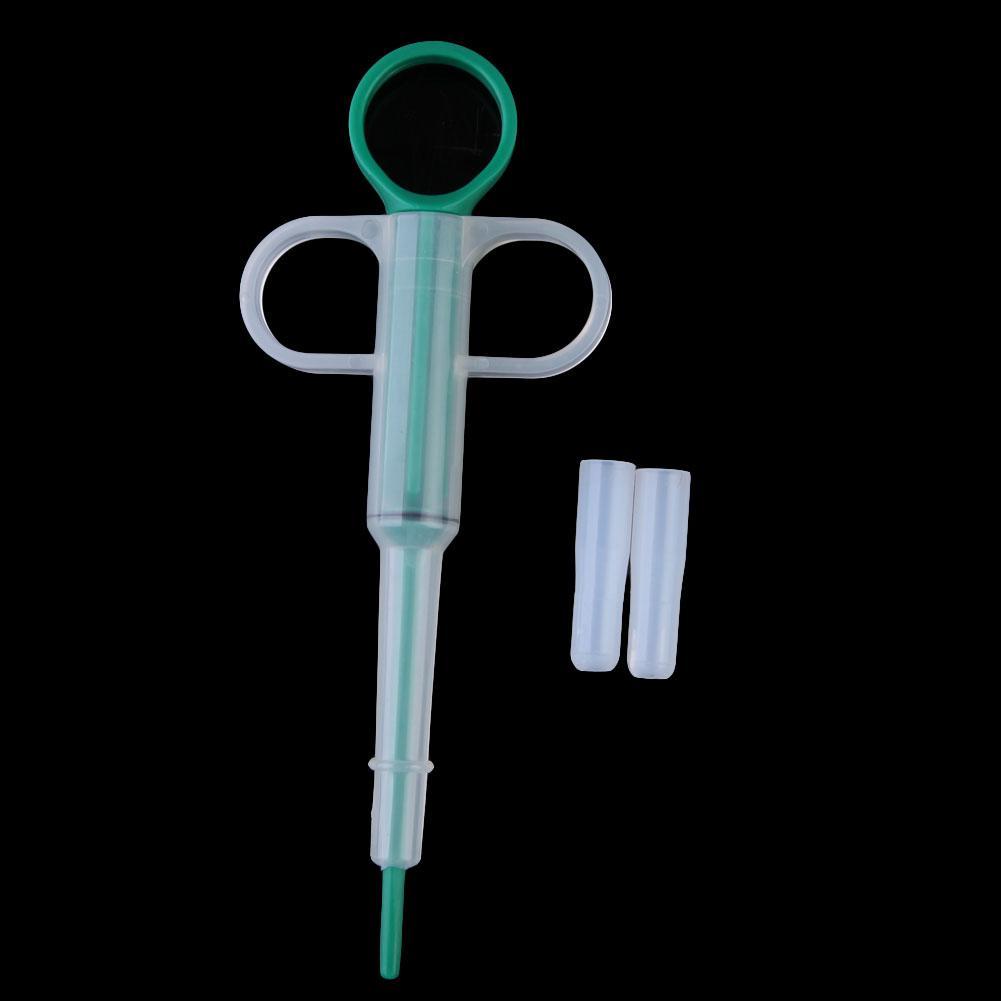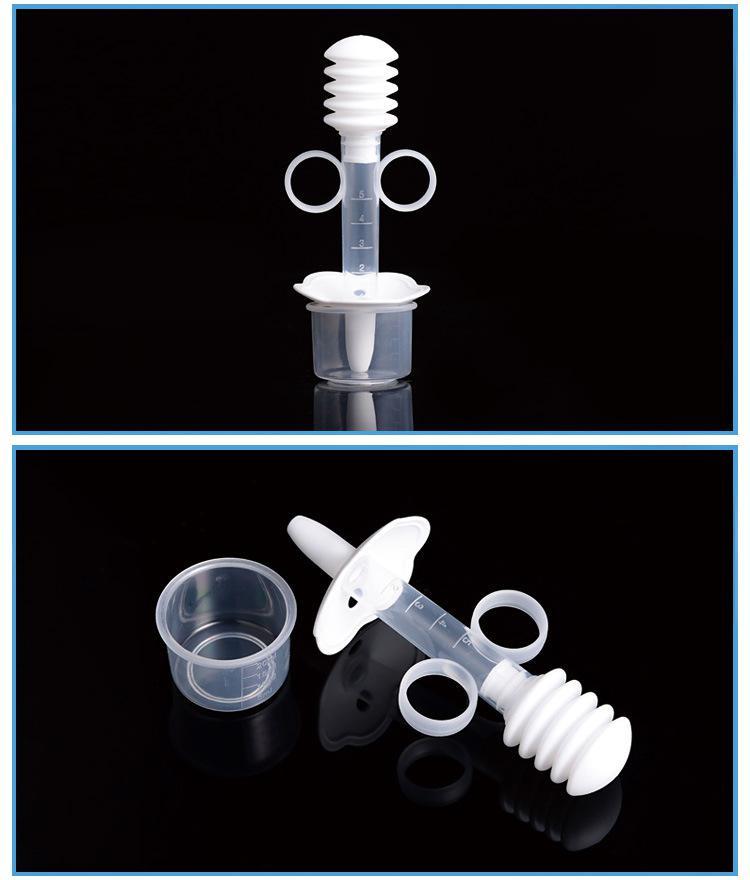The first image is the image on the left, the second image is the image on the right. Evaluate the accuracy of this statement regarding the images: "There are exactly four syringes in one of the images.". Is it true? Answer yes or no. No. 